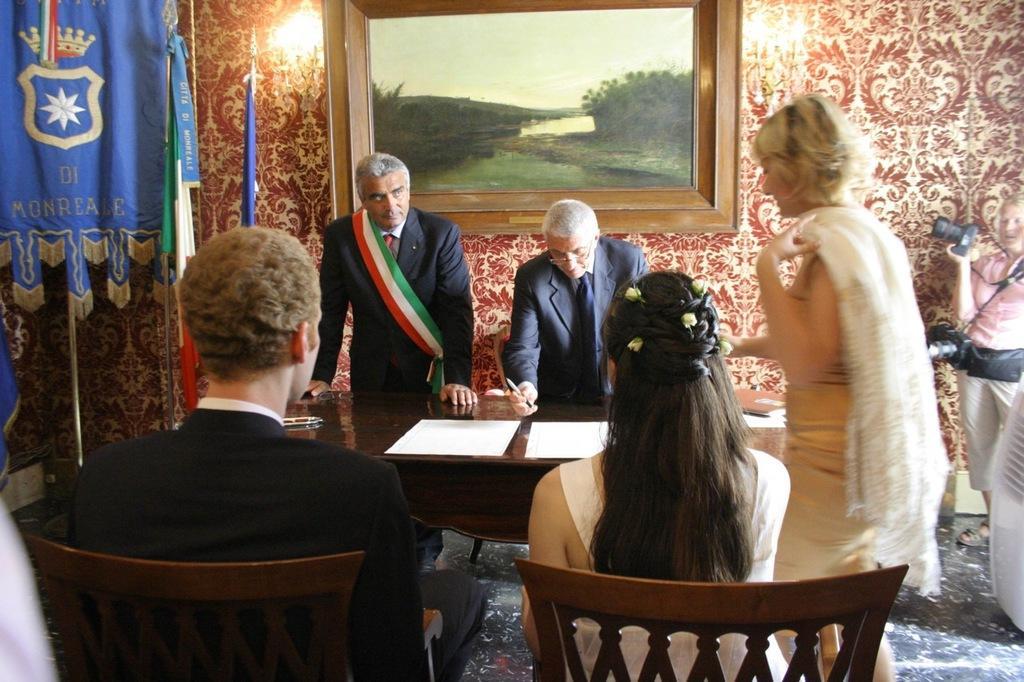Please provide a concise description of this image. In this picture there are two people sitting in the chairs in front of a table on which some papers were there. There are three members standing here. There are men and women in this picture. There are two flags here and a photo frame attached to the wall here. 